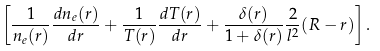Convert formula to latex. <formula><loc_0><loc_0><loc_500><loc_500>\left [ \frac { 1 } { n _ { e } ( r ) } \frac { d n _ { e } ( r ) } { d r } + \frac { 1 } { T ( r ) } \frac { d T ( r ) } { d r } + \frac { \delta ( r ) } { 1 + \delta ( r ) } \frac { 2 } { l ^ { 2 } } ( R - r ) \right ] .</formula> 